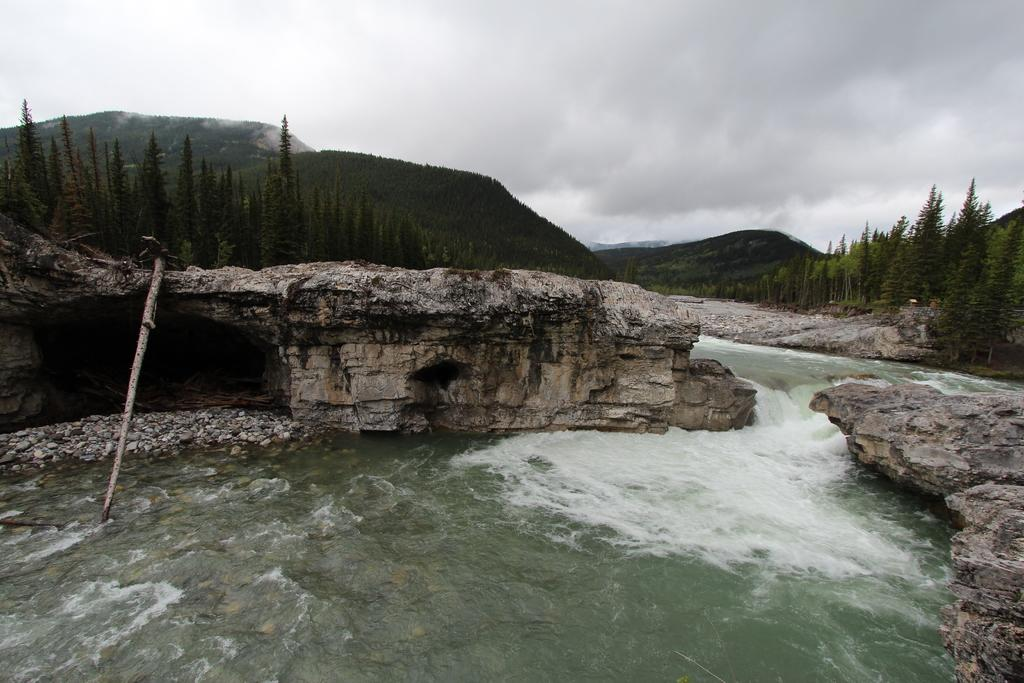What is one of the main elements in the image? There is water in the image. What other natural features can be seen in the image? There are stones, rocks, trees, and hills in the image. How would you describe the sky in the background of the image? The sky is cloudy in the background of the image. Can you see a bird's nest in the trees in the image? There is no bird's nest visible in the trees in the image. How many visitors are present in the image? There is no indication of any visitors in the image. 